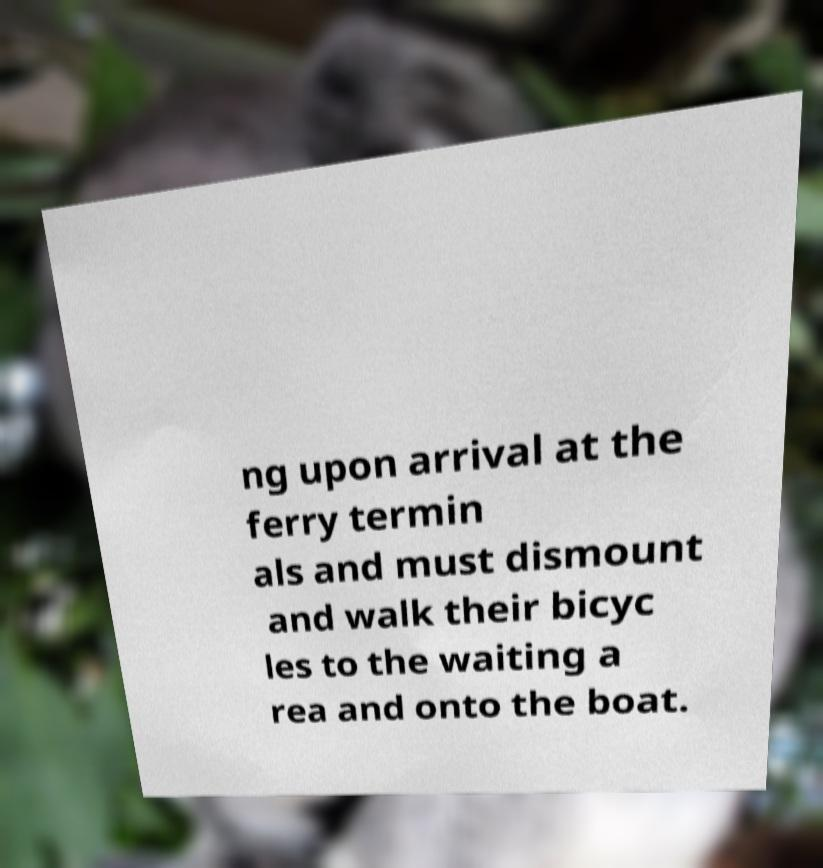Please identify and transcribe the text found in this image. ng upon arrival at the ferry termin als and must dismount and walk their bicyc les to the waiting a rea and onto the boat. 